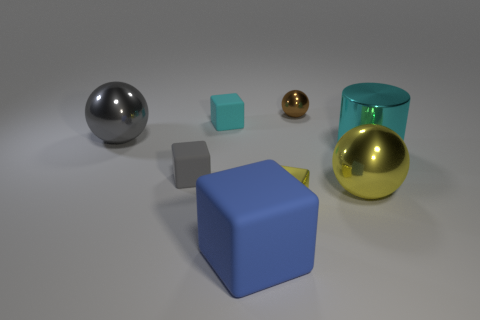Subtract 1 blocks. How many blocks are left? 3 Add 1 small cubes. How many objects exist? 9 Subtract all balls. How many objects are left? 5 Add 1 yellow metallic things. How many yellow metallic things exist? 3 Subtract 1 cyan blocks. How many objects are left? 7 Subtract all red rubber cubes. Subtract all cyan rubber cubes. How many objects are left? 7 Add 4 matte blocks. How many matte blocks are left? 7 